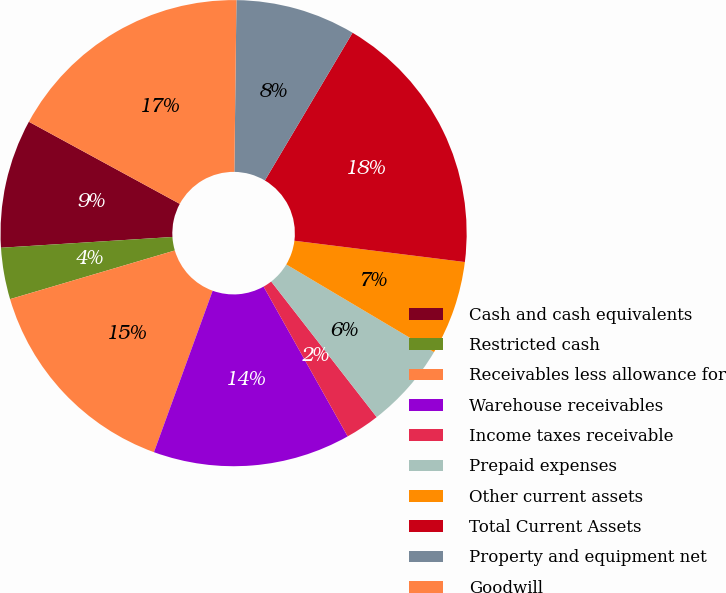Convert chart to OTSL. <chart><loc_0><loc_0><loc_500><loc_500><pie_chart><fcel>Cash and cash equivalents<fcel>Restricted cash<fcel>Receivables less allowance for<fcel>Warehouse receivables<fcel>Income taxes receivable<fcel>Prepaid expenses<fcel>Other current assets<fcel>Total Current Assets<fcel>Property and equipment net<fcel>Goodwill<nl><fcel>8.93%<fcel>3.57%<fcel>14.88%<fcel>13.69%<fcel>2.38%<fcel>5.95%<fcel>6.55%<fcel>18.45%<fcel>8.33%<fcel>17.26%<nl></chart> 